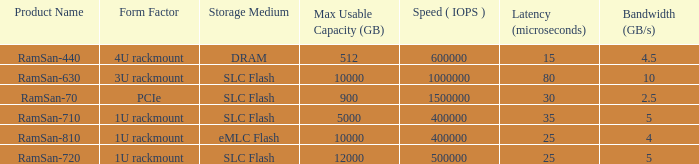What is the shape distortion for the range frequency of 10? 3U rackmount. 